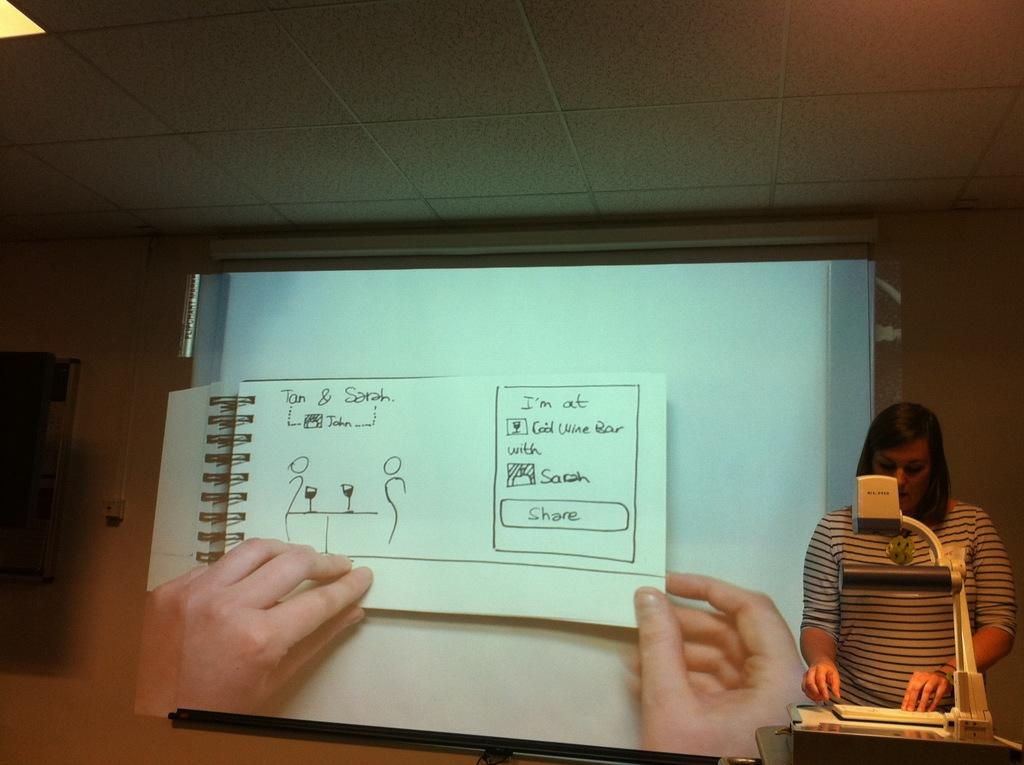<image>
Offer a succinct explanation of the picture presented. A women is using an overhead to show a drawing of Tom and Sarah. 